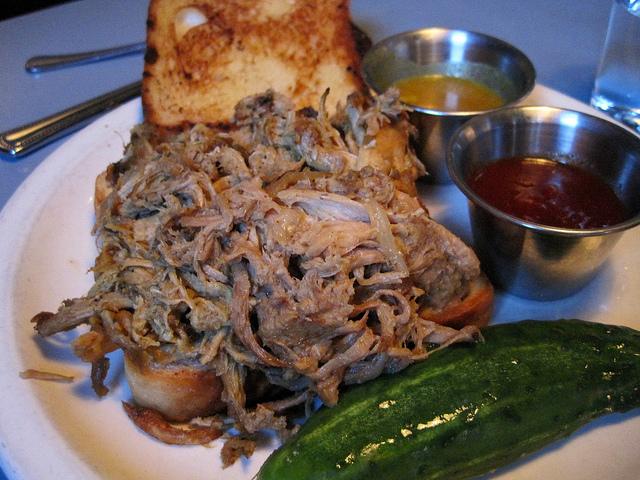What type of vegetable is shown?
Answer briefly. Cucumber. Is there a cutting board?
Concise answer only. No. Does this picture contain fish?
Quick response, please. No. What color is the plate?
Short answer required. White. What shape is the sandwich bread?
Quick response, please. Square. What is the name of the green vegetable?
Answer briefly. Cucumber. What is the green thing on the plate?
Concise answer only. Pickle. 